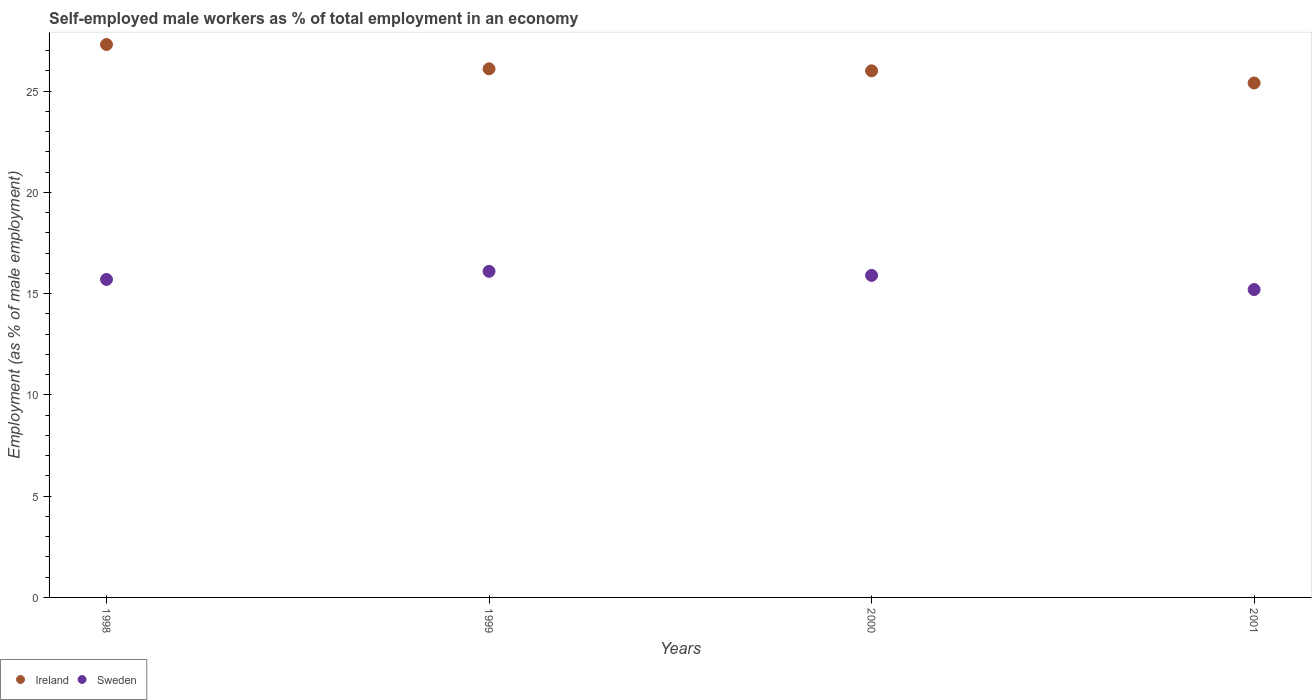Is the number of dotlines equal to the number of legend labels?
Provide a succinct answer. Yes. What is the percentage of self-employed male workers in Sweden in 2000?
Your answer should be very brief. 15.9. Across all years, what is the maximum percentage of self-employed male workers in Sweden?
Your response must be concise. 16.1. Across all years, what is the minimum percentage of self-employed male workers in Sweden?
Keep it short and to the point. 15.2. In which year was the percentage of self-employed male workers in Sweden maximum?
Offer a terse response. 1999. What is the total percentage of self-employed male workers in Ireland in the graph?
Make the answer very short. 104.8. What is the difference between the percentage of self-employed male workers in Sweden in 1999 and that in 2001?
Your response must be concise. 0.9. What is the difference between the percentage of self-employed male workers in Ireland in 1999 and the percentage of self-employed male workers in Sweden in 2001?
Ensure brevity in your answer.  10.9. What is the average percentage of self-employed male workers in Sweden per year?
Ensure brevity in your answer.  15.72. In the year 1999, what is the difference between the percentage of self-employed male workers in Ireland and percentage of self-employed male workers in Sweden?
Give a very brief answer. 10. What is the ratio of the percentage of self-employed male workers in Sweden in 1998 to that in 2000?
Provide a short and direct response. 0.99. Is the percentage of self-employed male workers in Sweden in 1999 less than that in 2000?
Your answer should be very brief. No. Is the difference between the percentage of self-employed male workers in Ireland in 1998 and 2001 greater than the difference between the percentage of self-employed male workers in Sweden in 1998 and 2001?
Keep it short and to the point. Yes. What is the difference between the highest and the second highest percentage of self-employed male workers in Sweden?
Make the answer very short. 0.2. What is the difference between the highest and the lowest percentage of self-employed male workers in Sweden?
Keep it short and to the point. 0.9. In how many years, is the percentage of self-employed male workers in Ireland greater than the average percentage of self-employed male workers in Ireland taken over all years?
Your answer should be compact. 1. Does the percentage of self-employed male workers in Sweden monotonically increase over the years?
Provide a short and direct response. No. Is the percentage of self-employed male workers in Sweden strictly greater than the percentage of self-employed male workers in Ireland over the years?
Provide a short and direct response. No. How many dotlines are there?
Your answer should be compact. 2. How many years are there in the graph?
Offer a very short reply. 4. What is the difference between two consecutive major ticks on the Y-axis?
Your answer should be very brief. 5. Does the graph contain grids?
Offer a very short reply. No. How many legend labels are there?
Offer a very short reply. 2. How are the legend labels stacked?
Give a very brief answer. Horizontal. What is the title of the graph?
Your answer should be compact. Self-employed male workers as % of total employment in an economy. Does "Portugal" appear as one of the legend labels in the graph?
Offer a very short reply. No. What is the label or title of the Y-axis?
Your answer should be compact. Employment (as % of male employment). What is the Employment (as % of male employment) of Ireland in 1998?
Give a very brief answer. 27.3. What is the Employment (as % of male employment) of Sweden in 1998?
Ensure brevity in your answer.  15.7. What is the Employment (as % of male employment) of Ireland in 1999?
Ensure brevity in your answer.  26.1. What is the Employment (as % of male employment) in Sweden in 1999?
Offer a terse response. 16.1. What is the Employment (as % of male employment) in Sweden in 2000?
Your answer should be compact. 15.9. What is the Employment (as % of male employment) of Ireland in 2001?
Provide a succinct answer. 25.4. What is the Employment (as % of male employment) in Sweden in 2001?
Provide a short and direct response. 15.2. Across all years, what is the maximum Employment (as % of male employment) of Ireland?
Your answer should be very brief. 27.3. Across all years, what is the maximum Employment (as % of male employment) of Sweden?
Provide a short and direct response. 16.1. Across all years, what is the minimum Employment (as % of male employment) of Ireland?
Offer a very short reply. 25.4. Across all years, what is the minimum Employment (as % of male employment) of Sweden?
Your answer should be compact. 15.2. What is the total Employment (as % of male employment) of Ireland in the graph?
Provide a succinct answer. 104.8. What is the total Employment (as % of male employment) in Sweden in the graph?
Keep it short and to the point. 62.9. What is the difference between the Employment (as % of male employment) of Ireland in 1998 and that in 1999?
Offer a very short reply. 1.2. What is the difference between the Employment (as % of male employment) of Sweden in 1998 and that in 1999?
Give a very brief answer. -0.4. What is the difference between the Employment (as % of male employment) in Sweden in 1998 and that in 2001?
Keep it short and to the point. 0.5. What is the difference between the Employment (as % of male employment) in Sweden in 2000 and that in 2001?
Your answer should be compact. 0.7. What is the difference between the Employment (as % of male employment) of Ireland in 1998 and the Employment (as % of male employment) of Sweden in 1999?
Provide a succinct answer. 11.2. What is the difference between the Employment (as % of male employment) of Ireland in 2000 and the Employment (as % of male employment) of Sweden in 2001?
Ensure brevity in your answer.  10.8. What is the average Employment (as % of male employment) of Ireland per year?
Make the answer very short. 26.2. What is the average Employment (as % of male employment) of Sweden per year?
Provide a short and direct response. 15.72. In the year 1998, what is the difference between the Employment (as % of male employment) of Ireland and Employment (as % of male employment) of Sweden?
Your answer should be compact. 11.6. What is the ratio of the Employment (as % of male employment) in Ireland in 1998 to that in 1999?
Give a very brief answer. 1.05. What is the ratio of the Employment (as % of male employment) in Sweden in 1998 to that in 1999?
Your answer should be very brief. 0.98. What is the ratio of the Employment (as % of male employment) of Sweden in 1998 to that in 2000?
Offer a terse response. 0.99. What is the ratio of the Employment (as % of male employment) of Ireland in 1998 to that in 2001?
Your answer should be very brief. 1.07. What is the ratio of the Employment (as % of male employment) in Sweden in 1998 to that in 2001?
Provide a short and direct response. 1.03. What is the ratio of the Employment (as % of male employment) in Ireland in 1999 to that in 2000?
Offer a terse response. 1. What is the ratio of the Employment (as % of male employment) in Sweden in 1999 to that in 2000?
Provide a succinct answer. 1.01. What is the ratio of the Employment (as % of male employment) in Ireland in 1999 to that in 2001?
Offer a terse response. 1.03. What is the ratio of the Employment (as % of male employment) of Sweden in 1999 to that in 2001?
Your answer should be compact. 1.06. What is the ratio of the Employment (as % of male employment) of Ireland in 2000 to that in 2001?
Provide a short and direct response. 1.02. What is the ratio of the Employment (as % of male employment) in Sweden in 2000 to that in 2001?
Ensure brevity in your answer.  1.05. What is the difference between the highest and the second highest Employment (as % of male employment) of Ireland?
Provide a short and direct response. 1.2. What is the difference between the highest and the lowest Employment (as % of male employment) in Ireland?
Give a very brief answer. 1.9. What is the difference between the highest and the lowest Employment (as % of male employment) of Sweden?
Your answer should be very brief. 0.9. 